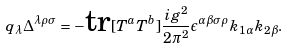Convert formula to latex. <formula><loc_0><loc_0><loc_500><loc_500>q _ { \lambda } \Delta ^ { \lambda \rho \sigma } = - \text {tr} [ T ^ { a } T ^ { b } ] \frac { i g ^ { 2 } } { 2 \pi ^ { 2 } } \epsilon ^ { \alpha \beta \sigma \rho } k _ { 1 \alpha } k _ { 2 \beta } .</formula> 